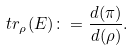Convert formula to latex. <formula><loc_0><loc_0><loc_500><loc_500>\ t r _ { \rho } ( E ) \colon = \frac { d ( \pi ) } { d ( \rho ) } .</formula> 